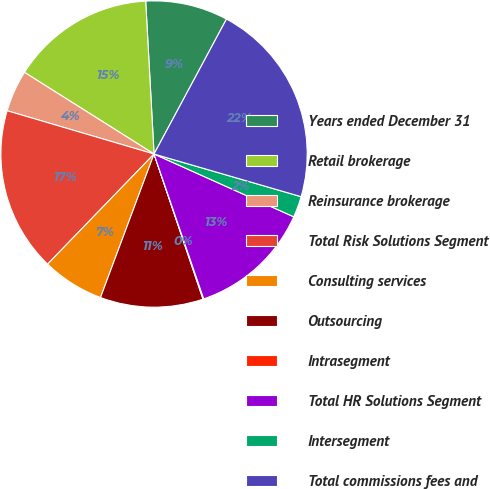Convert chart. <chart><loc_0><loc_0><loc_500><loc_500><pie_chart><fcel>Years ended December 31<fcel>Retail brokerage<fcel>Reinsurance brokerage<fcel>Total Risk Solutions Segment<fcel>Consulting services<fcel>Outsourcing<fcel>Intrasegment<fcel>Total HR Solutions Segment<fcel>Intersegment<fcel>Total commissions fees and<nl><fcel>8.71%<fcel>15.18%<fcel>4.39%<fcel>17.33%<fcel>6.55%<fcel>10.86%<fcel>0.08%<fcel>13.02%<fcel>2.23%<fcel>21.65%<nl></chart> 